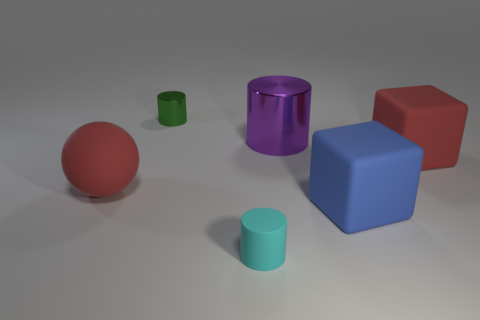Subtract all tiny shiny cylinders. How many cylinders are left? 2 Add 3 big red matte spheres. How many objects exist? 9 Subtract 1 cylinders. How many cylinders are left? 2 Subtract all balls. How many objects are left? 5 Add 6 big red rubber things. How many big red rubber things are left? 8 Add 4 cyan things. How many cyan things exist? 5 Subtract 0 cyan blocks. How many objects are left? 6 Subtract all blue cylinders. Subtract all purple balls. How many cylinders are left? 3 Subtract all small rubber things. Subtract all small cyan rubber cylinders. How many objects are left? 4 